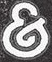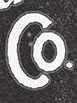Identify the words shown in these images in order, separated by a semicolon. &; Co 